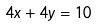Convert formula to latex. <formula><loc_0><loc_0><loc_500><loc_500>4 x + 4 y = 1 0</formula> 